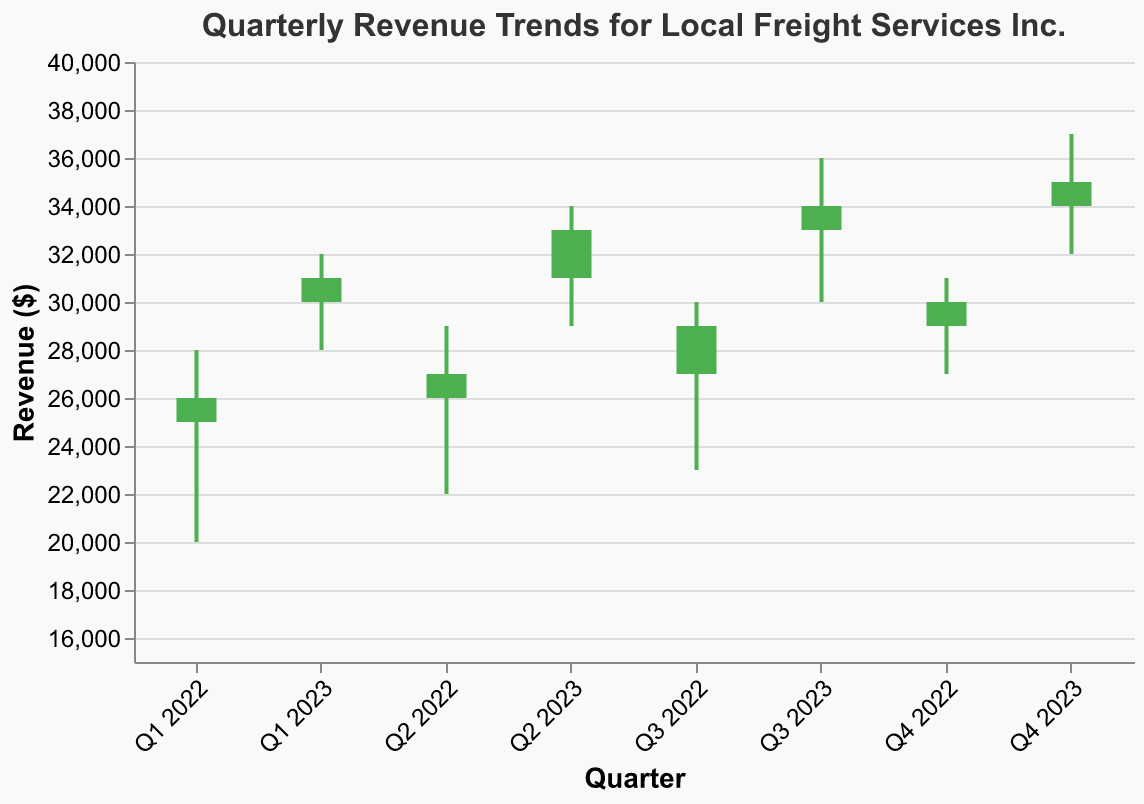What is the title of the figure? The title of the figure appears at the top and describes the contents of the plot. It is written in a larger font compared to other text elements.
Answer: Quarterly Revenue Trends for Local Freight Services Inc How many data points are shown in the figure? Each data point corresponds to a quarter and there are distinct bars and lines for each, representing four quarters in 2022 and four quarters in 2023.
Answer: 8 What was the highest revenue recorded, and in which quarter did it occur? The highest revenue is indicated by the peak of the "High" value for each quarter. By examining the highs, the highest revenue recorded was 37000 in Q4 2023.
Answer: 37000 in Q4 2023 In which quarters did the revenue close higher than it opened? Green bars indicate quarters where the revenue closed higher than it opened. Looking at the color of the bars, these quarters are Q1, Q2, Q3, and Q4 of 2023.
Answer: Q1, Q2, Q3, Q4 of 2023 What was the range (difference between high and low values) of revenue in Q2 2023? The range can be calculated by subtracting the Low value from the High value for Q2 2023, which is 34000 - 29000 = 5000.
Answer: 5000 How did the revenue trend from Q1 2022 to Q4 2023? Observing the "Close" values from each quarter, we can see if the values generally increased, decreased, or remained stable over time. The revenue shows an increasing trend from 26000 in Q1 2022 to 35000 in Q4 2023.
Answer: Increasing Which quarter had the smallest range between high and low revenue values, and what was that range? By looking for the smallest difference between the high and low values among all quarters, we find that Q4 2022 has the smallest range: 31000 - 27000 = 4000.
Answer: Q4 2022, 4000 By how much did the revenue increase from Q4 2022 to Q4 2023? Compare the "Close" value of Q4 2022 to that of Q4 2023. The increase is 35000 - 30000, which equals 5000.
Answer: 5000 What is the average closing revenue across all quarters? Summing up all the "Close" values and then dividing by the number of quarters: (26000 + 27000 + 29000 + 30000 + 31000 + 33000 + 34000 + 35000) / 8 = 30625.
Answer: 30625 Which quarter shows the highest volatility in revenue and how can this be determined? Volatility can be assessed by looking at the largest difference between the high and low values. Q4 2023 has the largest range difference (37000 - 32000 = 5000), indicating highest volatility.
Answer: Q4 2023 